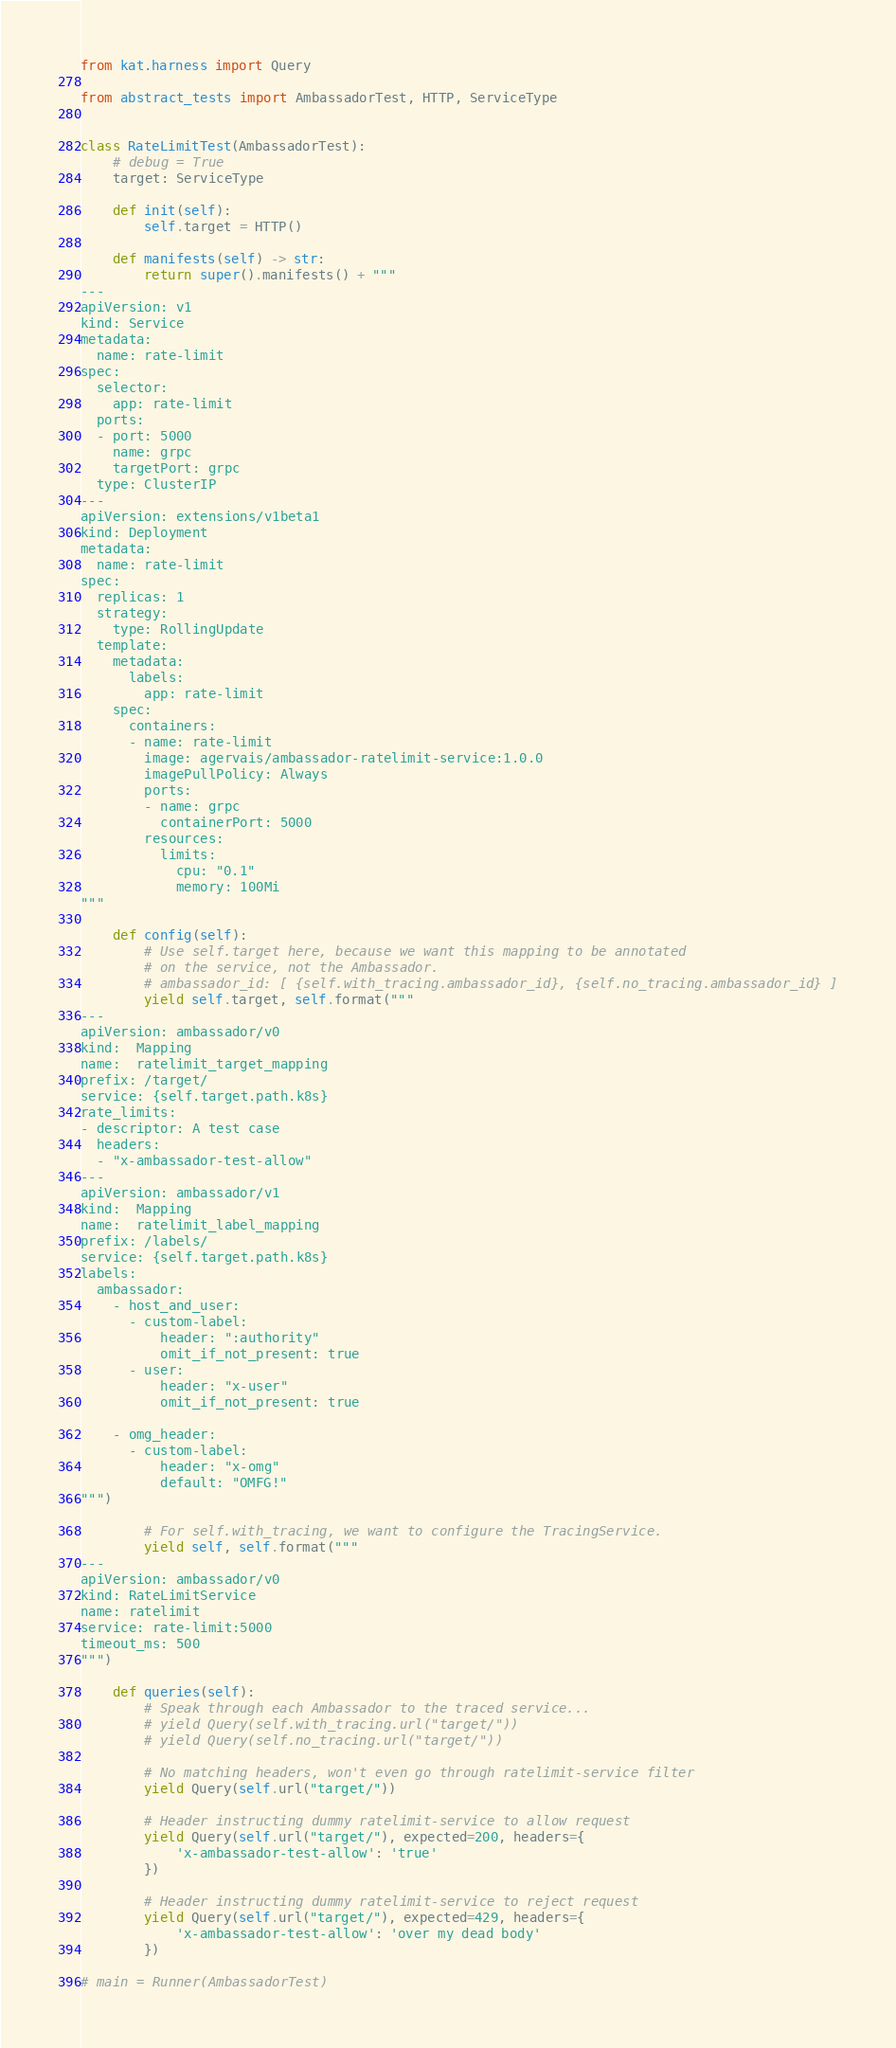<code> <loc_0><loc_0><loc_500><loc_500><_Python_>from kat.harness import Query

from abstract_tests import AmbassadorTest, HTTP, ServiceType


class RateLimitTest(AmbassadorTest):
    # debug = True
    target: ServiceType

    def init(self):
        self.target = HTTP()

    def manifests(self) -> str:
        return super().manifests() + """
---
apiVersion: v1
kind: Service
metadata:
  name: rate-limit
spec:
  selector:
    app: rate-limit
  ports:
  - port: 5000
    name: grpc
    targetPort: grpc
  type: ClusterIP
---
apiVersion: extensions/v1beta1
kind: Deployment
metadata:
  name: rate-limit
spec:
  replicas: 1
  strategy:
    type: RollingUpdate
  template:
    metadata:
      labels:
        app: rate-limit
    spec:
      containers:
      - name: rate-limit
        image: agervais/ambassador-ratelimit-service:1.0.0
        imagePullPolicy: Always
        ports:
        - name: grpc
          containerPort: 5000
        resources:
          limits:
            cpu: "0.1"
            memory: 100Mi
"""

    def config(self):
        # Use self.target here, because we want this mapping to be annotated
        # on the service, not the Ambassador.
        # ambassador_id: [ {self.with_tracing.ambassador_id}, {self.no_tracing.ambassador_id} ]
        yield self.target, self.format("""
---
apiVersion: ambassador/v0
kind:  Mapping
name:  ratelimit_target_mapping
prefix: /target/
service: {self.target.path.k8s}
rate_limits:
- descriptor: A test case
  headers:
  - "x-ambassador-test-allow"
---
apiVersion: ambassador/v1
kind:  Mapping
name:  ratelimit_label_mapping
prefix: /labels/
service: {self.target.path.k8s}
labels:
  ambassador:
    - host_and_user:
      - custom-label:
          header: ":authority"
          omit_if_not_present: true
      - user:
          header: "x-user"
          omit_if_not_present: true

    - omg_header:
      - custom-label:
          header: "x-omg"
          default: "OMFG!"
""")

        # For self.with_tracing, we want to configure the TracingService.
        yield self, self.format("""
---
apiVersion: ambassador/v0
kind: RateLimitService
name: ratelimit
service: rate-limit:5000
timeout_ms: 500
""")

    def queries(self):
        # Speak through each Ambassador to the traced service...
        # yield Query(self.with_tracing.url("target/"))
        # yield Query(self.no_tracing.url("target/"))

        # No matching headers, won't even go through ratelimit-service filter
        yield Query(self.url("target/"))

        # Header instructing dummy ratelimit-service to allow request
        yield Query(self.url("target/"), expected=200, headers={
            'x-ambassador-test-allow': 'true'
        })

        # Header instructing dummy ratelimit-service to reject request
        yield Query(self.url("target/"), expected=429, headers={
            'x-ambassador-test-allow': 'over my dead body'
        })

# main = Runner(AmbassadorTest)
</code> 